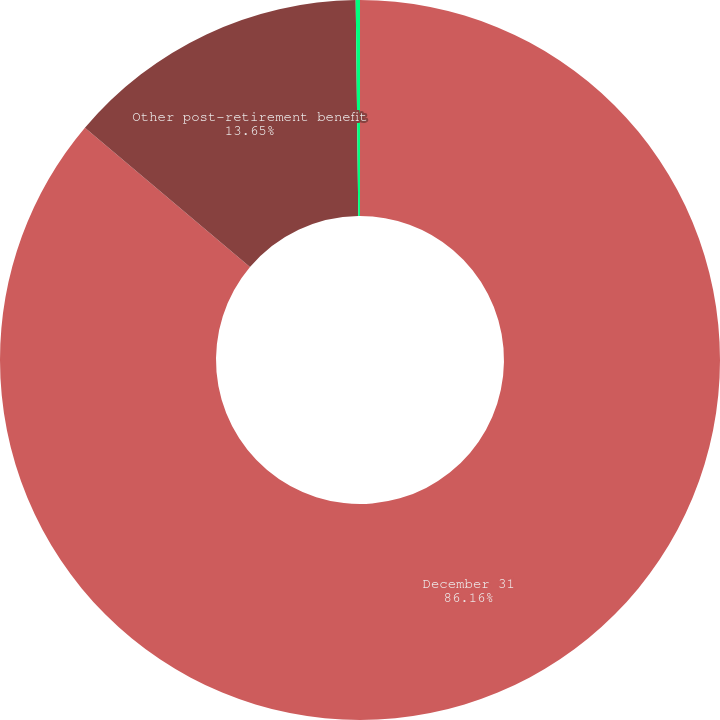Convert chart. <chart><loc_0><loc_0><loc_500><loc_500><pie_chart><fcel>December 31<fcel>Other post-retirement benefit<fcel>Benefit obligations discount<nl><fcel>86.16%<fcel>13.65%<fcel>0.19%<nl></chart> 